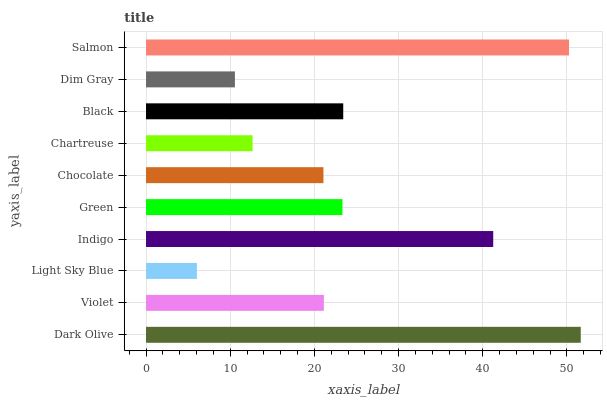Is Light Sky Blue the minimum?
Answer yes or no. Yes. Is Dark Olive the maximum?
Answer yes or no. Yes. Is Violet the minimum?
Answer yes or no. No. Is Violet the maximum?
Answer yes or no. No. Is Dark Olive greater than Violet?
Answer yes or no. Yes. Is Violet less than Dark Olive?
Answer yes or no. Yes. Is Violet greater than Dark Olive?
Answer yes or no. No. Is Dark Olive less than Violet?
Answer yes or no. No. Is Green the high median?
Answer yes or no. Yes. Is Violet the low median?
Answer yes or no. Yes. Is Dim Gray the high median?
Answer yes or no. No. Is Indigo the low median?
Answer yes or no. No. 